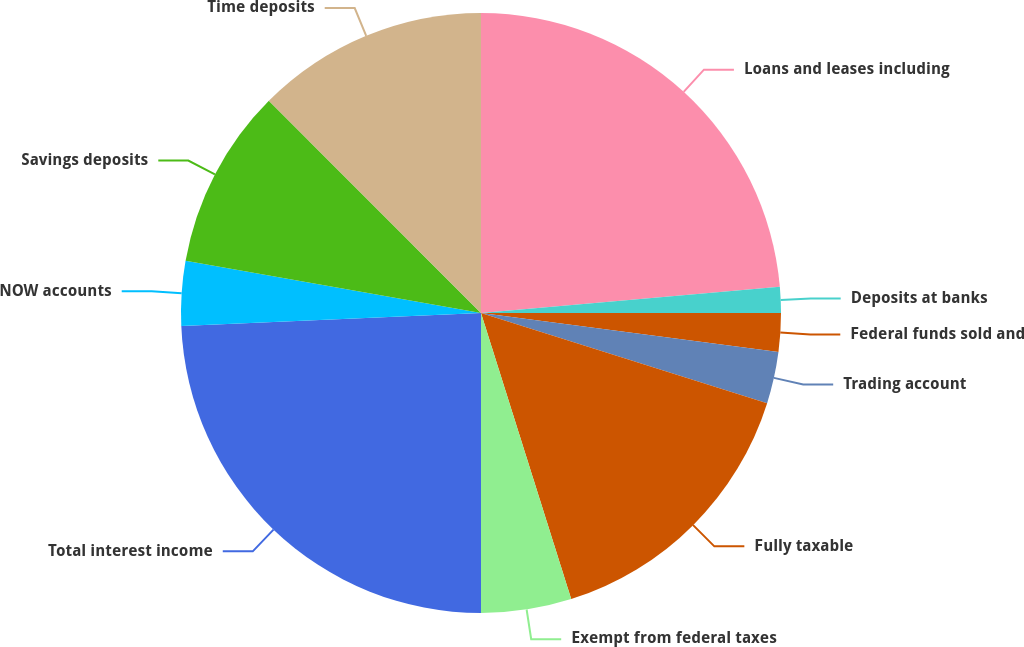<chart> <loc_0><loc_0><loc_500><loc_500><pie_chart><fcel>Loans and leases including<fcel>Deposits at banks<fcel>Federal funds sold and<fcel>Trading account<fcel>Fully taxable<fcel>Exempt from federal taxes<fcel>Total interest income<fcel>NOW accounts<fcel>Savings deposits<fcel>Time deposits<nl><fcel>23.61%<fcel>1.39%<fcel>2.08%<fcel>2.78%<fcel>15.28%<fcel>4.86%<fcel>24.31%<fcel>3.47%<fcel>9.72%<fcel>12.5%<nl></chart> 